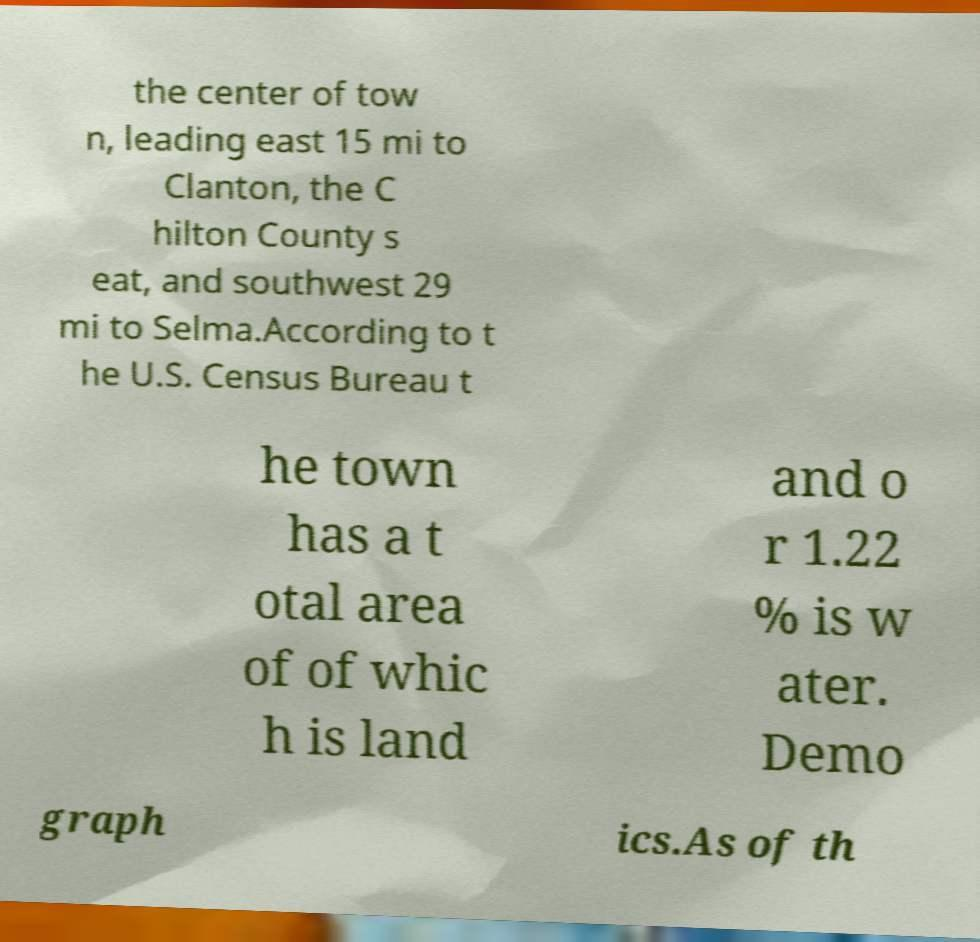Please read and relay the text visible in this image. What does it say? the center of tow n, leading east 15 mi to Clanton, the C hilton County s eat, and southwest 29 mi to Selma.According to t he U.S. Census Bureau t he town has a t otal area of of whic h is land and o r 1.22 % is w ater. Demo graph ics.As of th 